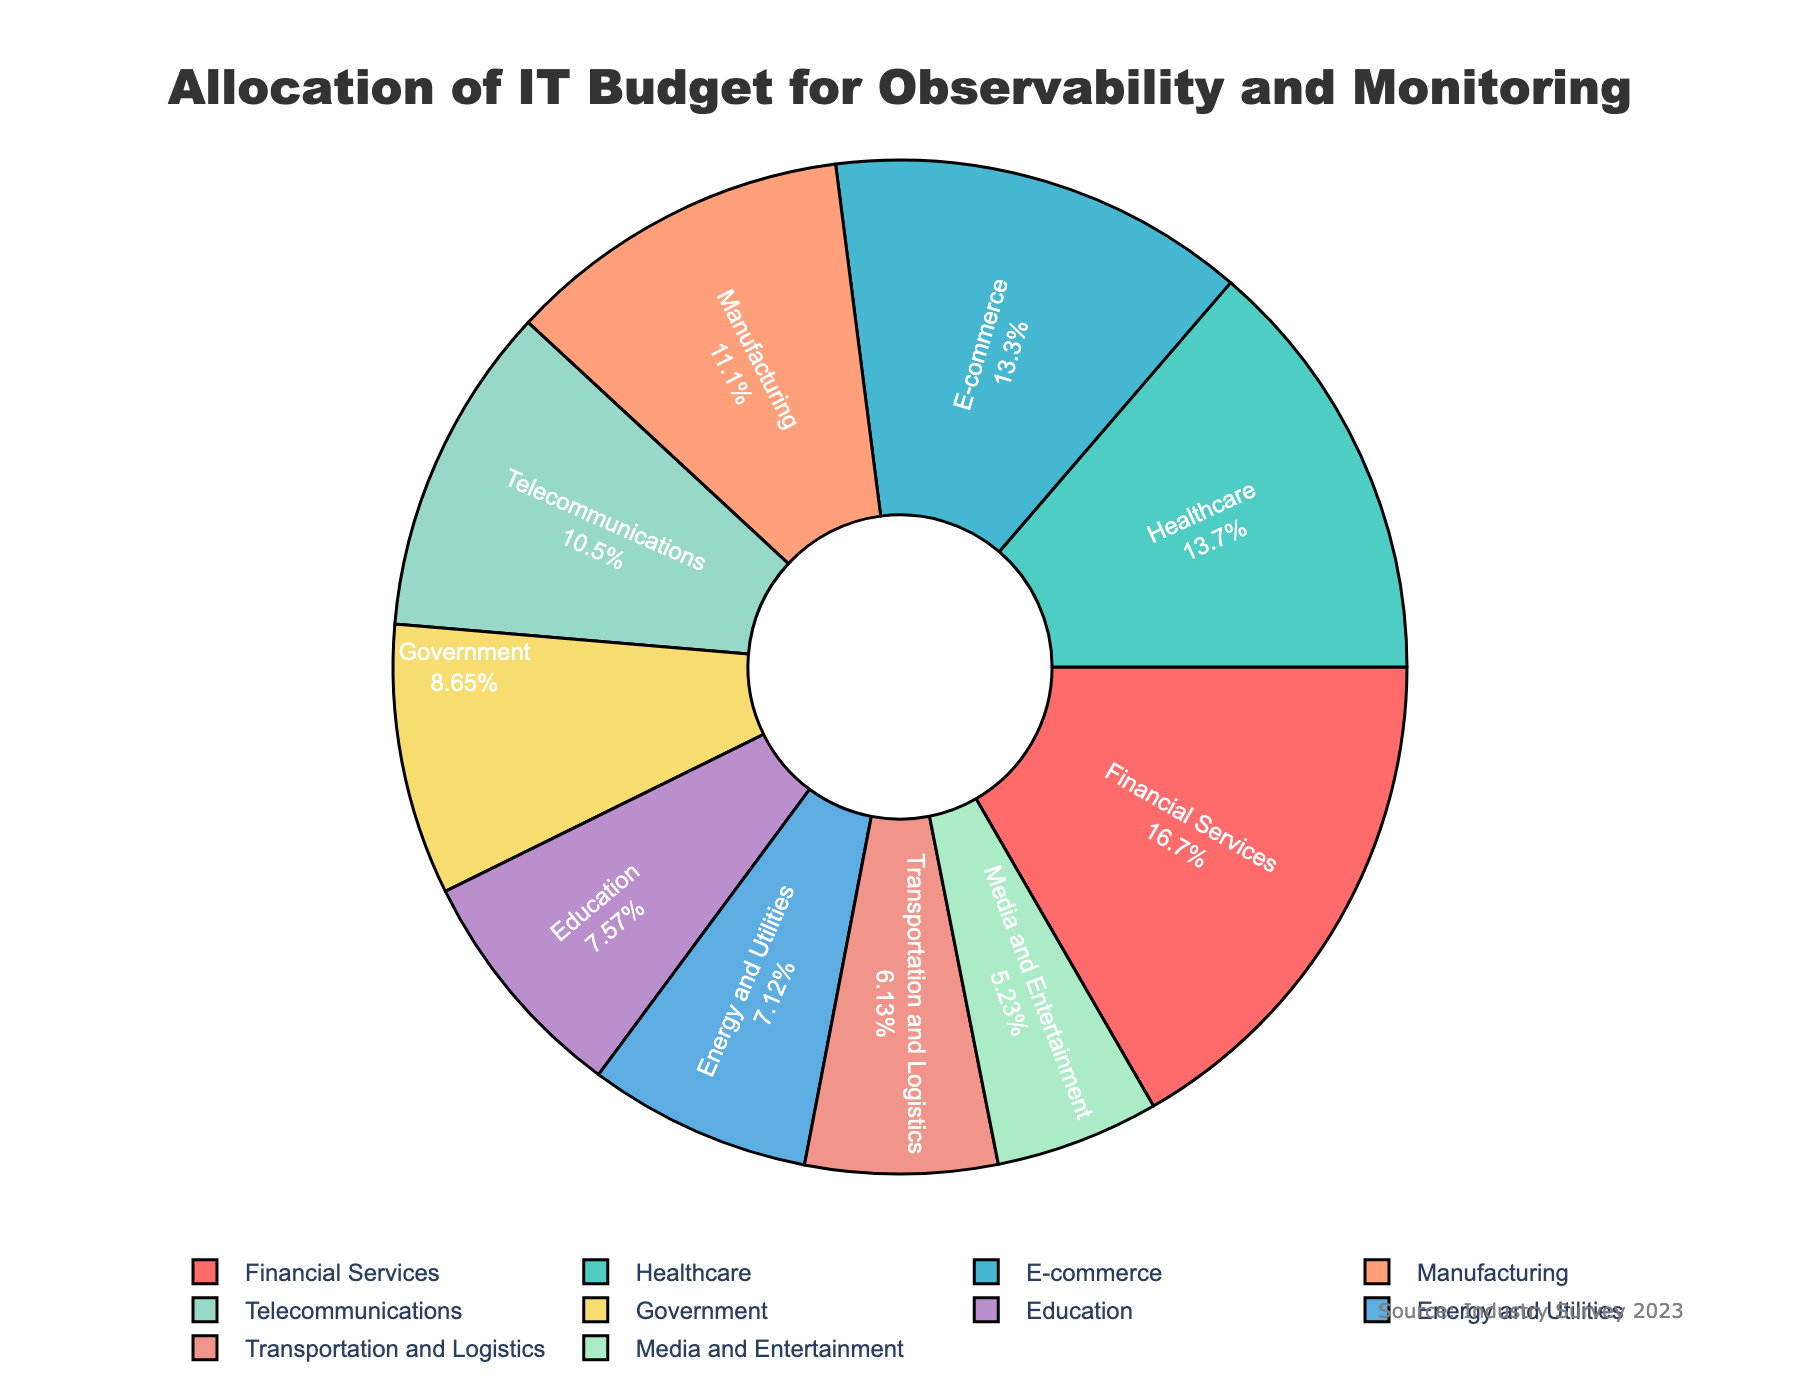What's the industry sector with the highest allocation of IT budget for observability and monitoring? The pie chart indicates that Financial Services has the largest segment, showing it has the highest allocation of 18.5%.
Answer: Financial Services What percentage of the IT budget is allocated to Healthcare and E-commerce combined? From the chart, Healthcare has a 15.2% allocation and E-commerce has a 14.8% allocation. Adding these together gives 15.2 + 14.8 = 30.
Answer: 30% Which industry sectors have an IT budget allocation of less than 10%? The chart shows the slices for Government (9.6%), Education (8.4%), Energy and Utilities (7.9%), Transportation and Logistics (6.8%), and Media and Entertainment (5.8%) are all below 10%.
Answer: Government, Education, Energy and Utilities, Transportation and Logistics, Media and Entertainment How much more is the IT budget allocation for Financial Services compared to Manufacturing? Financial Services has an 18.5% allocation, and Manufacturing has a 12.3% allocation. The difference is 18.5 - 12.3 = 6.2.
Answer: 6.2% What is the average IT budget allocation for Telecommunications, Government, and Education? Adding the allocations for Telecommunications (11.7%), Government (9.6%), and Education (8.4%), we get 11.7 + 9.6 + 8.4 = 29.7. Dividing by 3: 29.7 / 3 = 9.9.
Answer: 9.9% Which two industry sectors have nearly the same percentage allocation, and what are their values? Healthcare (15.2%) and E-commerce (14.8%) have nearly the same percentage allocation with a difference of only 0.4%.
Answer: Healthcare and E-commerce, 15.2% and 14.8% What's the combined IT budget allocation for Financial Services, Healthcare, and E-commerce? Adding the values for Financial Services (18.5%), Healthcare (15.2%), and E-commerce (14.8%) results in 18.5 + 15.2 + 14.8 = 48.5%.
Answer: 48.5% Rank the top three industries by IT budget allocation. The top three industries based on the chart are Financial Services (18.5%), Healthcare (15.2%), and E-commerce (14.8%).
Answer: Financial Services, Healthcare, E-commerce 